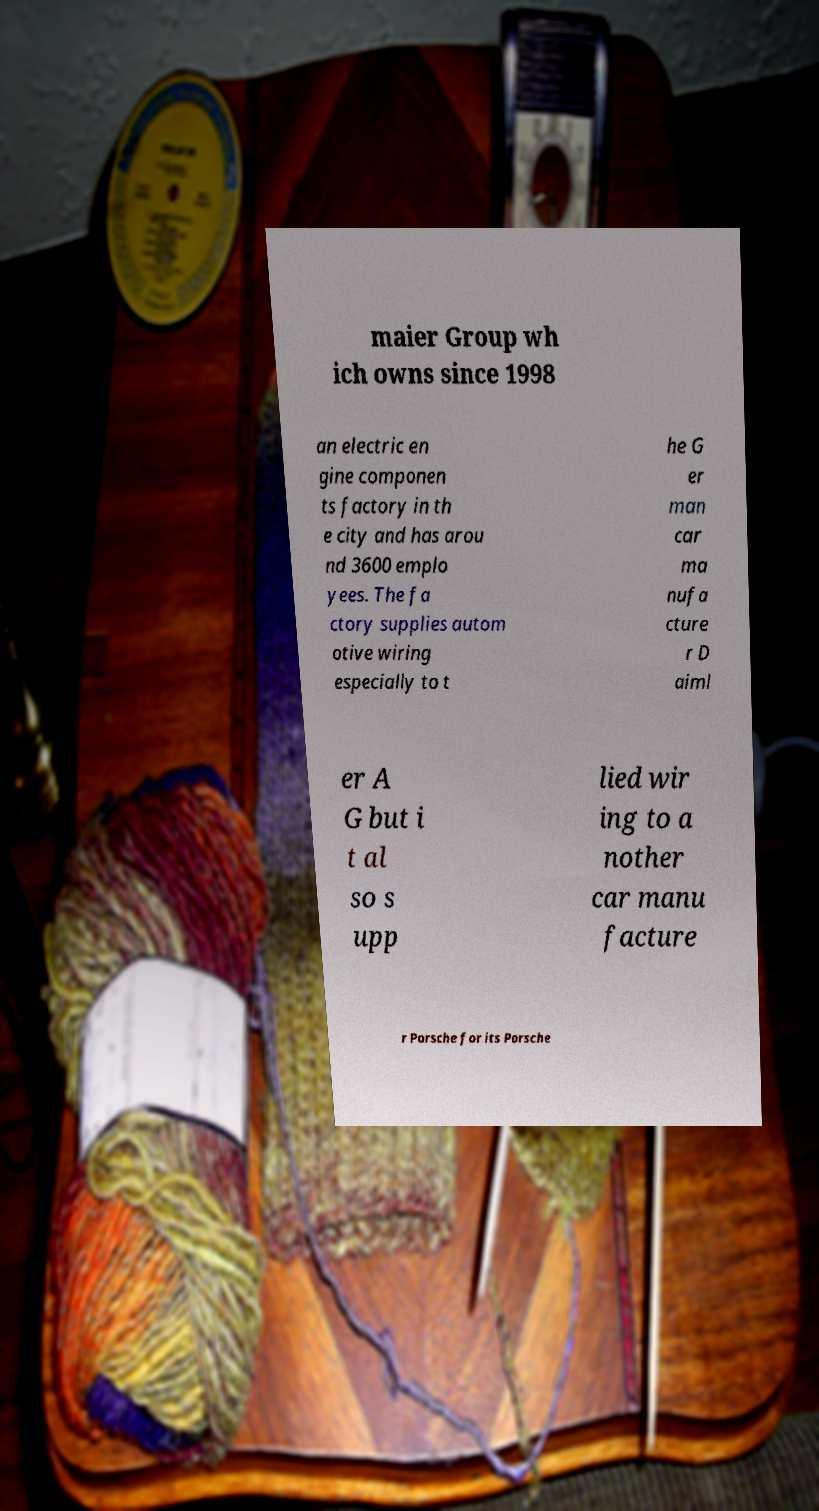Can you read and provide the text displayed in the image?This photo seems to have some interesting text. Can you extract and type it out for me? maier Group wh ich owns since 1998 an electric en gine componen ts factory in th e city and has arou nd 3600 emplo yees. The fa ctory supplies autom otive wiring especially to t he G er man car ma nufa cture r D aiml er A G but i t al so s upp lied wir ing to a nother car manu facture r Porsche for its Porsche 